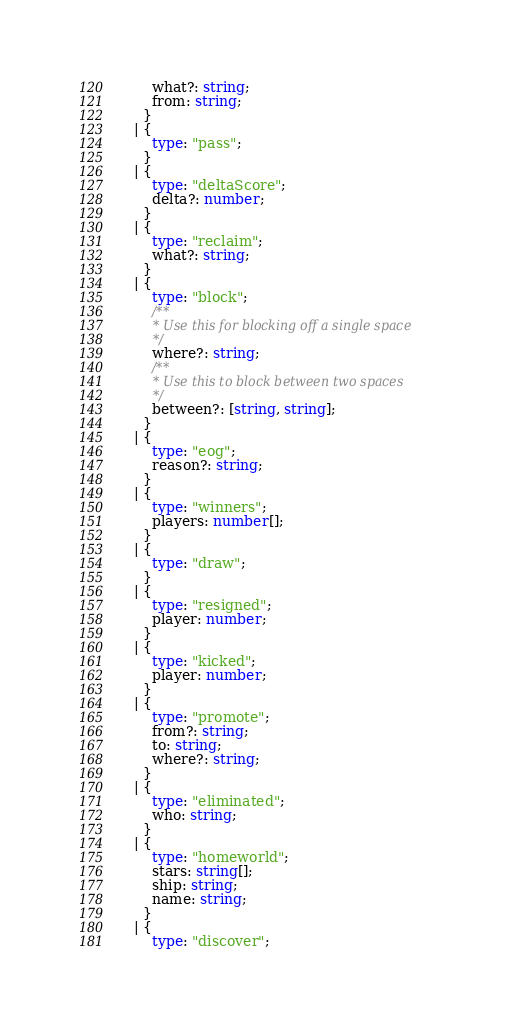<code> <loc_0><loc_0><loc_500><loc_500><_TypeScript_>      what?: string;
      from: string;
    }
  | {
      type: "pass";
    }
  | {
      type: "deltaScore";
      delta?: number;
    }
  | {
      type: "reclaim";
      what?: string;
    }
  | {
      type: "block";
      /**
       * Use this for blocking off a single space
       */
      where?: string;
      /**
       * Use this to block between two spaces
       */
      between?: [string, string];
    }
  | {
      type: "eog";
      reason?: string;
    }
  | {
      type: "winners";
      players: number[];
    }
  | {
      type: "draw";
    }
  | {
      type: "resigned";
      player: number;
    }
  | {
      type: "kicked";
      player: number;
    }
  | {
      type: "promote";
      from?: string;
      to: string;
      where?: string;
    }
  | {
      type: "eliminated";
      who: string;
    }
  | {
      type: "homeworld";
      stars: string[];
      ship: string;
      name: string;
    }
  | {
      type: "discover";</code> 